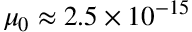Convert formula to latex. <formula><loc_0><loc_0><loc_500><loc_500>\mu _ { 0 } \approx 2 . 5 \times 1 0 ^ { - 1 5 }</formula> 